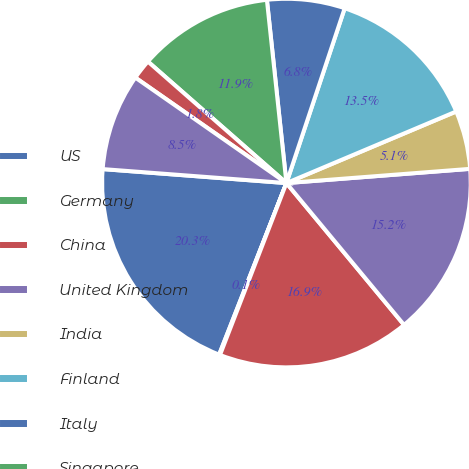Convert chart. <chart><loc_0><loc_0><loc_500><loc_500><pie_chart><fcel>US<fcel>Germany<fcel>China<fcel>United Kingdom<fcel>India<fcel>Finland<fcel>Italy<fcel>Singapore<fcel>Brazil<fcel>Netherlands<nl><fcel>20.26%<fcel>0.08%<fcel>16.89%<fcel>15.21%<fcel>5.12%<fcel>13.53%<fcel>6.81%<fcel>11.85%<fcel>1.76%<fcel>8.49%<nl></chart> 